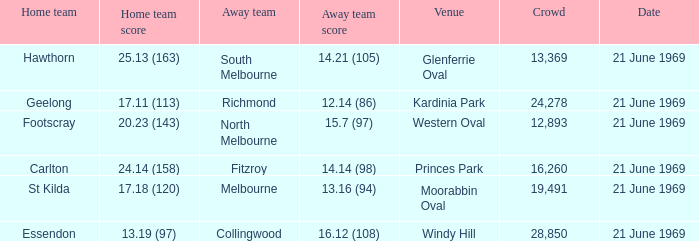On which occasion did an away team manage to score 15.7 (97)? 21 June 1969. 